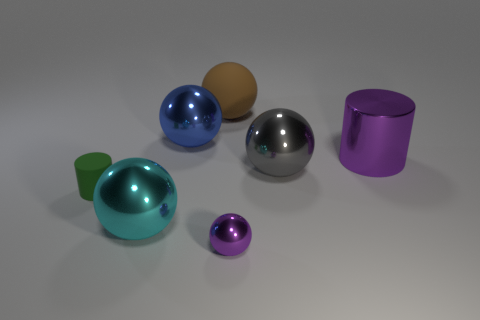What number of big objects are either blue metal cylinders or cyan metallic objects?
Your answer should be compact. 1. There is a cylinder that is behind the small object that is left of the tiny shiny ball; is there a shiny thing in front of it?
Offer a terse response. Yes. Is there a purple object of the same size as the gray metal thing?
Offer a very short reply. Yes. What material is the cylinder that is the same size as the blue metallic sphere?
Your response must be concise. Metal. Does the cyan thing have the same size as the cylinder that is left of the purple shiny sphere?
Your answer should be compact. No. How many matte objects are blue spheres or cyan spheres?
Offer a very short reply. 0. What number of other things have the same shape as the large gray thing?
Your answer should be very brief. 4. There is a cylinder that is the same color as the small ball; what material is it?
Make the answer very short. Metal. There is a cylinder that is to the right of the large brown rubber sphere; is it the same size as the shiny thing that is behind the large purple thing?
Ensure brevity in your answer.  Yes. There is a small thing right of the big rubber ball; what is its shape?
Provide a succinct answer. Sphere. 